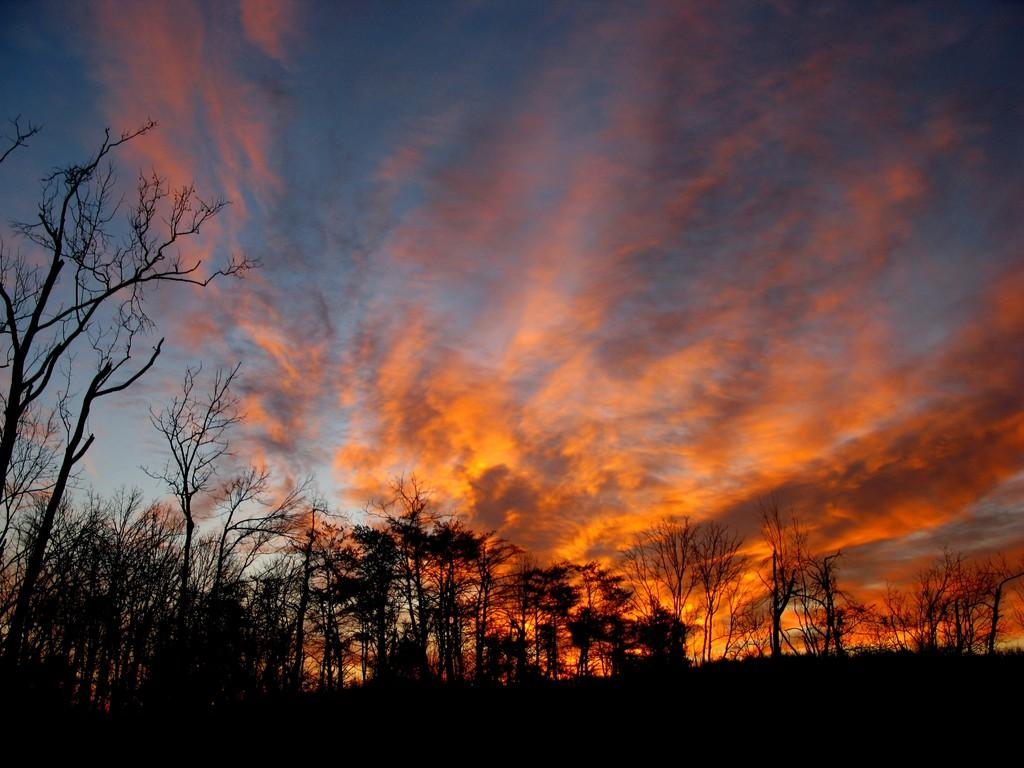What type of vegetation can be seen in the image? There are trees in the image. What is visible in the background of the image? The sky is visible in the background of the image. What can be observed in the sky in the image? Clouds are present in the sky. What type of oven is visible in the image? There is no oven present in the image. Can you tell me the parent's name of the person in the image? There is no person present in the image, so it is not possible to determine the name of their parent. 